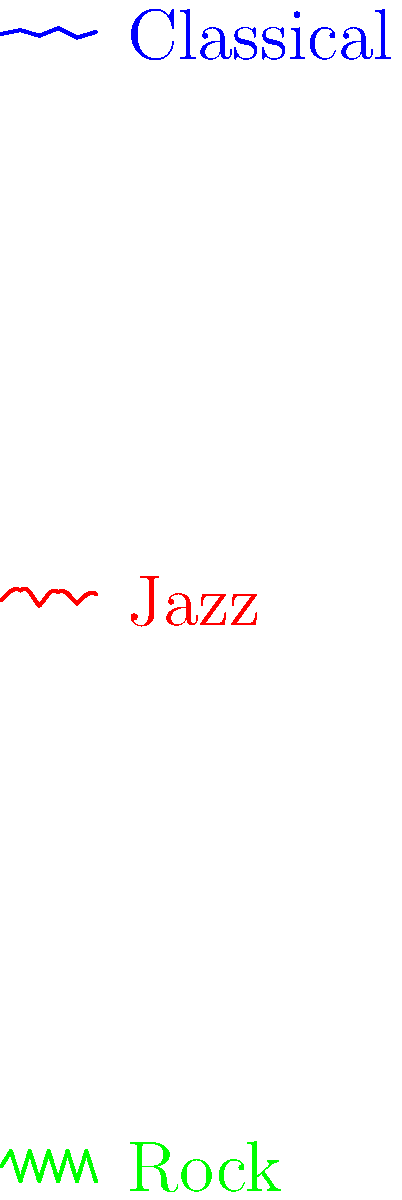As a pianist who collaborates on literary-musical projects, you're analyzing sound wave patterns of different genres. Which genre is represented by the middle (red) wave pattern, and how does it differ from the others? To answer this question, let's analyze the characteristics of each wave pattern:

1. Top (blue) wave:
   - Smooth, gentle curves
   - Relatively consistent amplitude
   - Regular, predictable pattern
   This represents Classical music, known for its structured and refined composition.

2. Middle (red) wave:
   - Irregular, curved pattern
   - Varying amplitudes
   - Smooth transitions between peaks and troughs
   This represents Jazz music, characterized by its improvisational nature and syncopated rhythms.

3. Bottom (green) wave:
   - Sharp, angular transitions
   - High amplitude variations
   - Consistent high-low pattern
   This represents Rock music, known for its strong beats and electric instruments.

The middle (red) wave pattern represents Jazz. It differs from the others in the following ways:
- More irregular than Classical, but smoother than Rock
- Shows improvisation-like patterns with unpredictable curves
- Has varying amplitudes, but not as extreme as Rock
- Demonstrates a flow that's neither as structured as Classical nor as repetitive as Rock

These characteristics align with Jazz's improvisational nature, complex rhythms, and blend of structure and spontaneity.
Answer: Jazz; irregular curved pattern with varying amplitudes, representing improvisation and syncopated rhythms. 